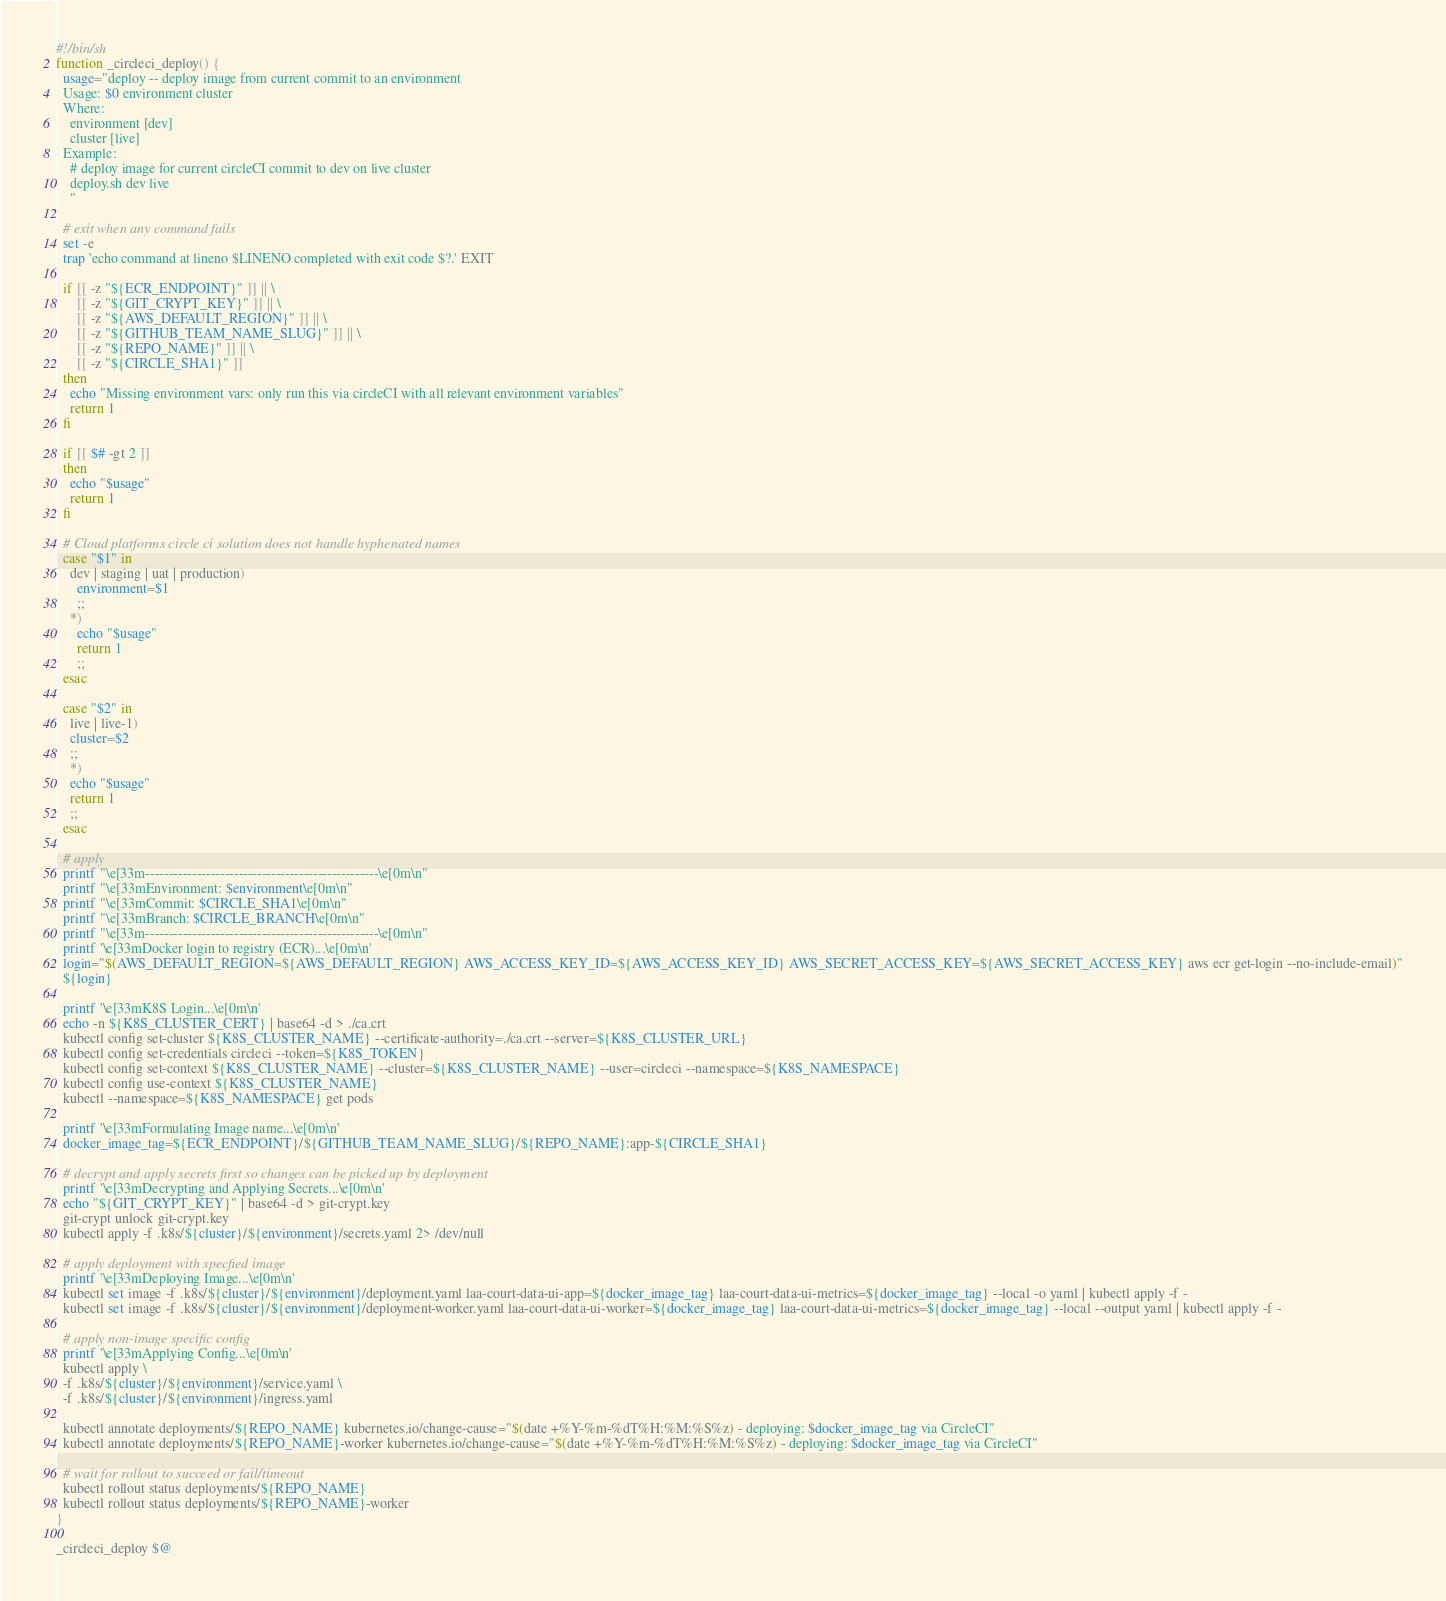<code> <loc_0><loc_0><loc_500><loc_500><_Bash_>#!/bin/sh
function _circleci_deploy() {
  usage="deploy -- deploy image from current commit to an environment
  Usage: $0 environment cluster
  Where:
    environment [dev]
    cluster [live]
  Example:
    # deploy image for current circleCI commit to dev on live cluster
    deploy.sh dev live
    "

  # exit when any command fails
  set -e
  trap 'echo command at lineno $LINENO completed with exit code $?.' EXIT

  if [[ -z "${ECR_ENDPOINT}" ]] || \
      [[ -z "${GIT_CRYPT_KEY}" ]] || \
      [[ -z "${AWS_DEFAULT_REGION}" ]] || \
      [[ -z "${GITHUB_TEAM_NAME_SLUG}" ]] || \
      [[ -z "${REPO_NAME}" ]] || \
      [[ -z "${CIRCLE_SHA1}" ]]
  then
    echo "Missing environment vars: only run this via circleCI with all relevant environment variables"
    return 1
  fi

  if [[ $# -gt 2 ]]
  then
    echo "$usage"
    return 1
  fi

  # Cloud platforms circle ci solution does not handle hyphenated names
  case "$1" in
    dev | staging | uat | production)
      environment=$1
      ;;
    *)
      echo "$usage"
      return 1
      ;;
  esac

  case "$2" in
    live | live-1)
    cluster=$2
    ;;
    *)
    echo "$usage"
    return 1
    ;;
  esac

  # apply
  printf "\e[33m--------------------------------------------------\e[0m\n"
  printf "\e[33mEnvironment: $environment\e[0m\n"
  printf "\e[33mCommit: $CIRCLE_SHA1\e[0m\n"
  printf "\e[33mBranch: $CIRCLE_BRANCH\e[0m\n"
  printf "\e[33m--------------------------------------------------\e[0m\n"
  printf '\e[33mDocker login to registry (ECR)...\e[0m\n'
  login="$(AWS_DEFAULT_REGION=${AWS_DEFAULT_REGION} AWS_ACCESS_KEY_ID=${AWS_ACCESS_KEY_ID} AWS_SECRET_ACCESS_KEY=${AWS_SECRET_ACCESS_KEY} aws ecr get-login --no-include-email)"
  ${login}

  printf '\e[33mK8S Login...\e[0m\n'
  echo -n ${K8S_CLUSTER_CERT} | base64 -d > ./ca.crt
  kubectl config set-cluster ${K8S_CLUSTER_NAME} --certificate-authority=./ca.crt --server=${K8S_CLUSTER_URL}
  kubectl config set-credentials circleci --token=${K8S_TOKEN}
  kubectl config set-context ${K8S_CLUSTER_NAME} --cluster=${K8S_CLUSTER_NAME} --user=circleci --namespace=${K8S_NAMESPACE}
  kubectl config use-context ${K8S_CLUSTER_NAME}
  kubectl --namespace=${K8S_NAMESPACE} get pods

  printf '\e[33mFormulating Image name...\e[0m\n'
  docker_image_tag=${ECR_ENDPOINT}/${GITHUB_TEAM_NAME_SLUG}/${REPO_NAME}:app-${CIRCLE_SHA1}

  # decrypt and apply secrets first so changes can be picked up by deployment
  printf '\e[33mDecrypting and Applying Secrets...\e[0m\n'
  echo "${GIT_CRYPT_KEY}" | base64 -d > git-crypt.key
  git-crypt unlock git-crypt.key
  kubectl apply -f .k8s/${cluster}/${environment}/secrets.yaml 2> /dev/null

  # apply deployment with specfied image
  printf '\e[33mDeploying Image...\e[0m\n'
  kubectl set image -f .k8s/${cluster}/${environment}/deployment.yaml laa-court-data-ui-app=${docker_image_tag} laa-court-data-ui-metrics=${docker_image_tag} --local -o yaml | kubectl apply -f -
  kubectl set image -f .k8s/${cluster}/${environment}/deployment-worker.yaml laa-court-data-ui-worker=${docker_image_tag} laa-court-data-ui-metrics=${docker_image_tag} --local --output yaml | kubectl apply -f -

  # apply non-image specific config
  printf '\e[33mApplying Config...\e[0m\n'
  kubectl apply \
  -f .k8s/${cluster}/${environment}/service.yaml \
  -f .k8s/${cluster}/${environment}/ingress.yaml

  kubectl annotate deployments/${REPO_NAME} kubernetes.io/change-cause="$(date +%Y-%m-%dT%H:%M:%S%z) - deploying: $docker_image_tag via CircleCI"
  kubectl annotate deployments/${REPO_NAME}-worker kubernetes.io/change-cause="$(date +%Y-%m-%dT%H:%M:%S%z) - deploying: $docker_image_tag via CircleCI"

  # wait for rollout to succeed or fail/timeout
  kubectl rollout status deployments/${REPO_NAME}
  kubectl rollout status deployments/${REPO_NAME}-worker
}

_circleci_deploy $@
</code> 